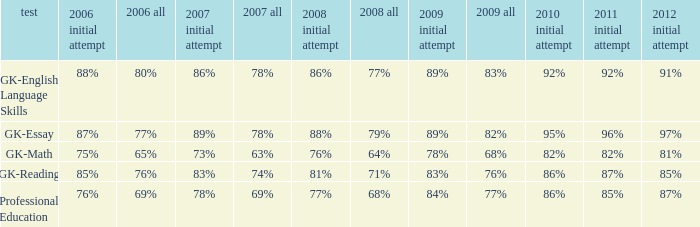What is the percentage for 2008 First time when in 2006 it was 85%? 81%. 